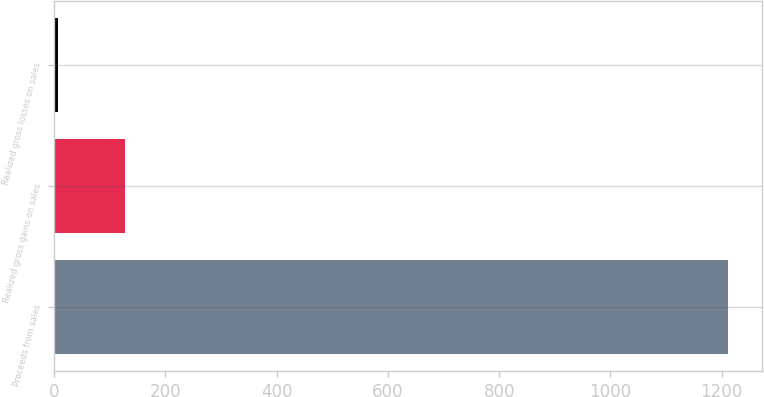<chart> <loc_0><loc_0><loc_500><loc_500><bar_chart><fcel>Proceeds from sales<fcel>Realized gross gains on sales<fcel>Realized gross losses on sales<nl><fcel>1212.1<fcel>126.7<fcel>6.1<nl></chart> 